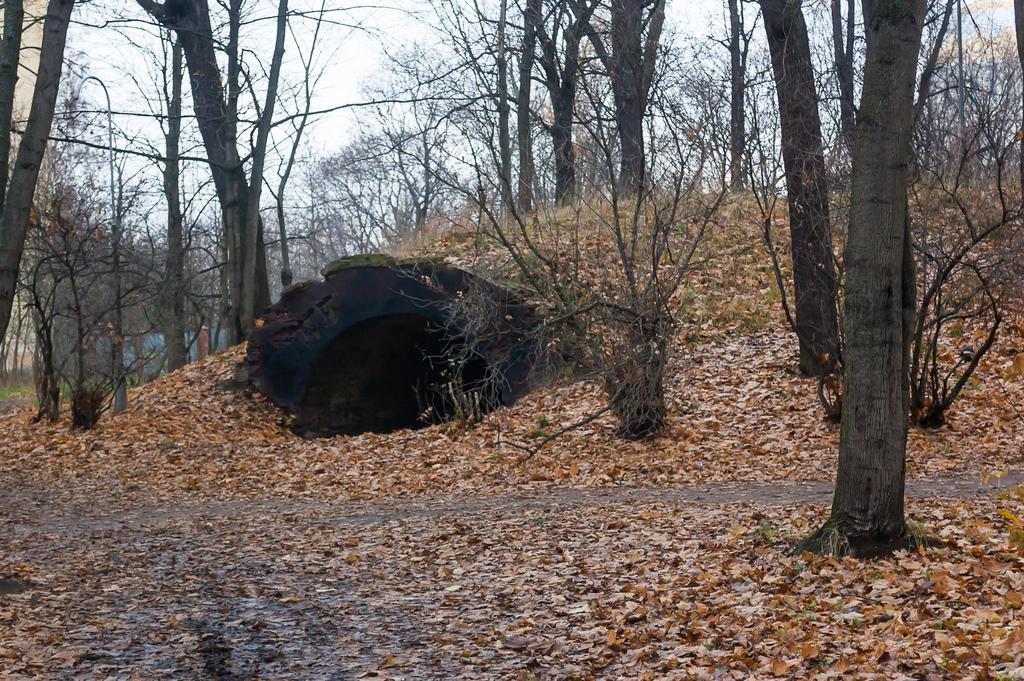Describe this image in one or two sentences. In this image I can see in the middle there is the cave and there are trees. At the top it is the sky, at the bottom there are dried leaves. 